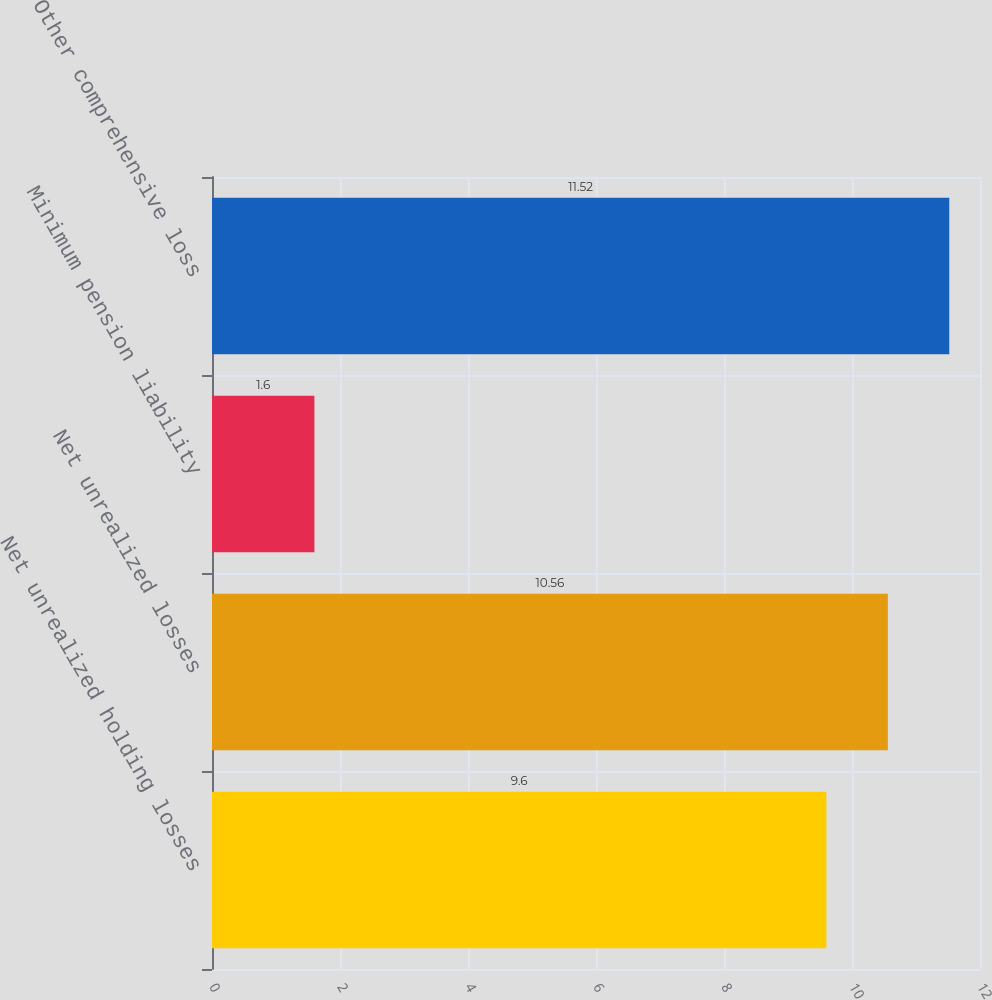<chart> <loc_0><loc_0><loc_500><loc_500><bar_chart><fcel>Net unrealized holding losses<fcel>Net unrealized losses<fcel>Minimum pension liability<fcel>Other comprehensive loss<nl><fcel>9.6<fcel>10.56<fcel>1.6<fcel>11.52<nl></chart> 